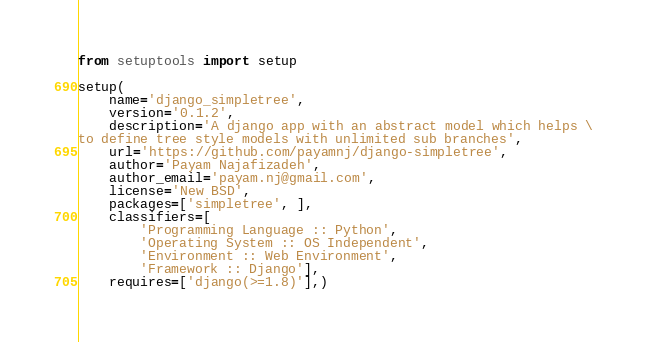Convert code to text. <code><loc_0><loc_0><loc_500><loc_500><_Python_>from setuptools import setup

setup(
    name='django_simpletree',
    version='0.1.2',
    description='A django app with an abstract model which helps \
to define tree style models with unlimited sub branches',
    url='https://github.com/payamnj/django-simpletree',
    author='Payam Najafizadeh',
    author_email='payam.nj@gmail.com',
    license='New BSD',
    packages=['simpletree', ],
    classifiers=[
        'Programming Language :: Python',
        'Operating System :: OS Independent',
        'Environment :: Web Environment',
        'Framework :: Django'],
    requires=['django(>=1.8)'],)
</code> 